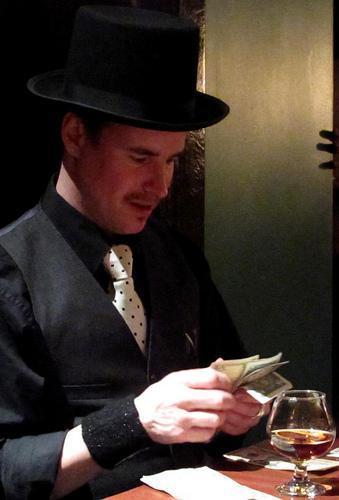How many carrots are on top of the cartoon image?
Give a very brief answer. 0. 